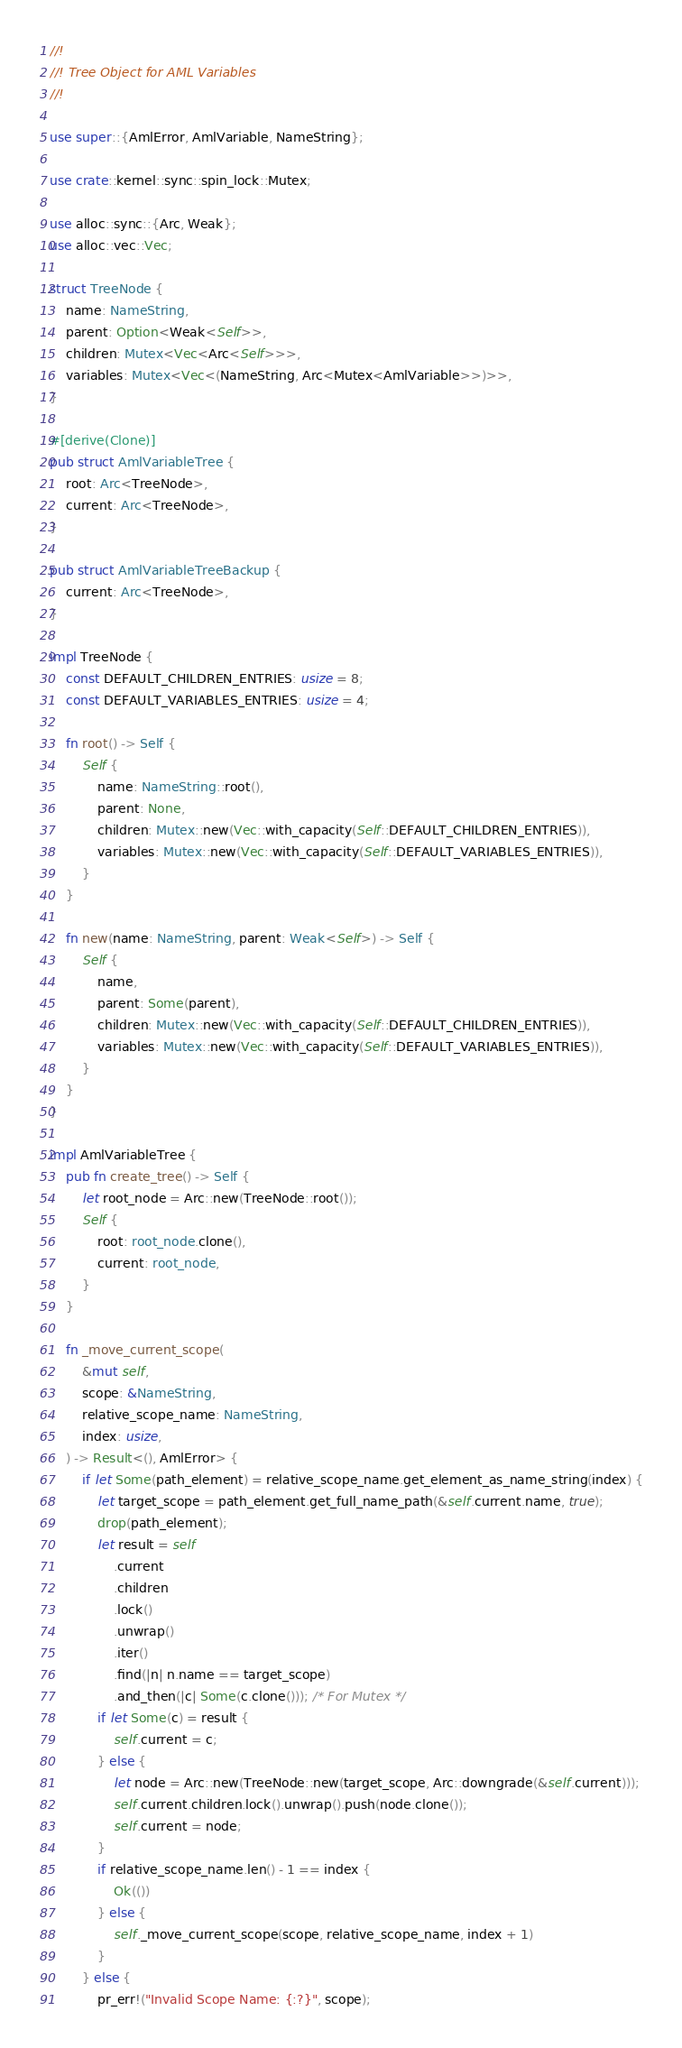Convert code to text. <code><loc_0><loc_0><loc_500><loc_500><_Rust_>//!
//! Tree Object for AML Variables
//!

use super::{AmlError, AmlVariable, NameString};

use crate::kernel::sync::spin_lock::Mutex;

use alloc::sync::{Arc, Weak};
use alloc::vec::Vec;

struct TreeNode {
    name: NameString,
    parent: Option<Weak<Self>>,
    children: Mutex<Vec<Arc<Self>>>,
    variables: Mutex<Vec<(NameString, Arc<Mutex<AmlVariable>>)>>,
}

#[derive(Clone)]
pub struct AmlVariableTree {
    root: Arc<TreeNode>,
    current: Arc<TreeNode>,
}

pub struct AmlVariableTreeBackup {
    current: Arc<TreeNode>,
}

impl TreeNode {
    const DEFAULT_CHILDREN_ENTRIES: usize = 8;
    const DEFAULT_VARIABLES_ENTRIES: usize = 4;

    fn root() -> Self {
        Self {
            name: NameString::root(),
            parent: None,
            children: Mutex::new(Vec::with_capacity(Self::DEFAULT_CHILDREN_ENTRIES)),
            variables: Mutex::new(Vec::with_capacity(Self::DEFAULT_VARIABLES_ENTRIES)),
        }
    }

    fn new(name: NameString, parent: Weak<Self>) -> Self {
        Self {
            name,
            parent: Some(parent),
            children: Mutex::new(Vec::with_capacity(Self::DEFAULT_CHILDREN_ENTRIES)),
            variables: Mutex::new(Vec::with_capacity(Self::DEFAULT_VARIABLES_ENTRIES)),
        }
    }
}

impl AmlVariableTree {
    pub fn create_tree() -> Self {
        let root_node = Arc::new(TreeNode::root());
        Self {
            root: root_node.clone(),
            current: root_node,
        }
    }

    fn _move_current_scope(
        &mut self,
        scope: &NameString,
        relative_scope_name: NameString,
        index: usize,
    ) -> Result<(), AmlError> {
        if let Some(path_element) = relative_scope_name.get_element_as_name_string(index) {
            let target_scope = path_element.get_full_name_path(&self.current.name, true);
            drop(path_element);
            let result = self
                .current
                .children
                .lock()
                .unwrap()
                .iter()
                .find(|n| n.name == target_scope)
                .and_then(|c| Some(c.clone())); /* For Mutex */
            if let Some(c) = result {
                self.current = c;
            } else {
                let node = Arc::new(TreeNode::new(target_scope, Arc::downgrade(&self.current)));
                self.current.children.lock().unwrap().push(node.clone());
                self.current = node;
            }
            if relative_scope_name.len() - 1 == index {
                Ok(())
            } else {
                self._move_current_scope(scope, relative_scope_name, index + 1)
            }
        } else {
            pr_err!("Invalid Scope Name: {:?}", scope);</code> 